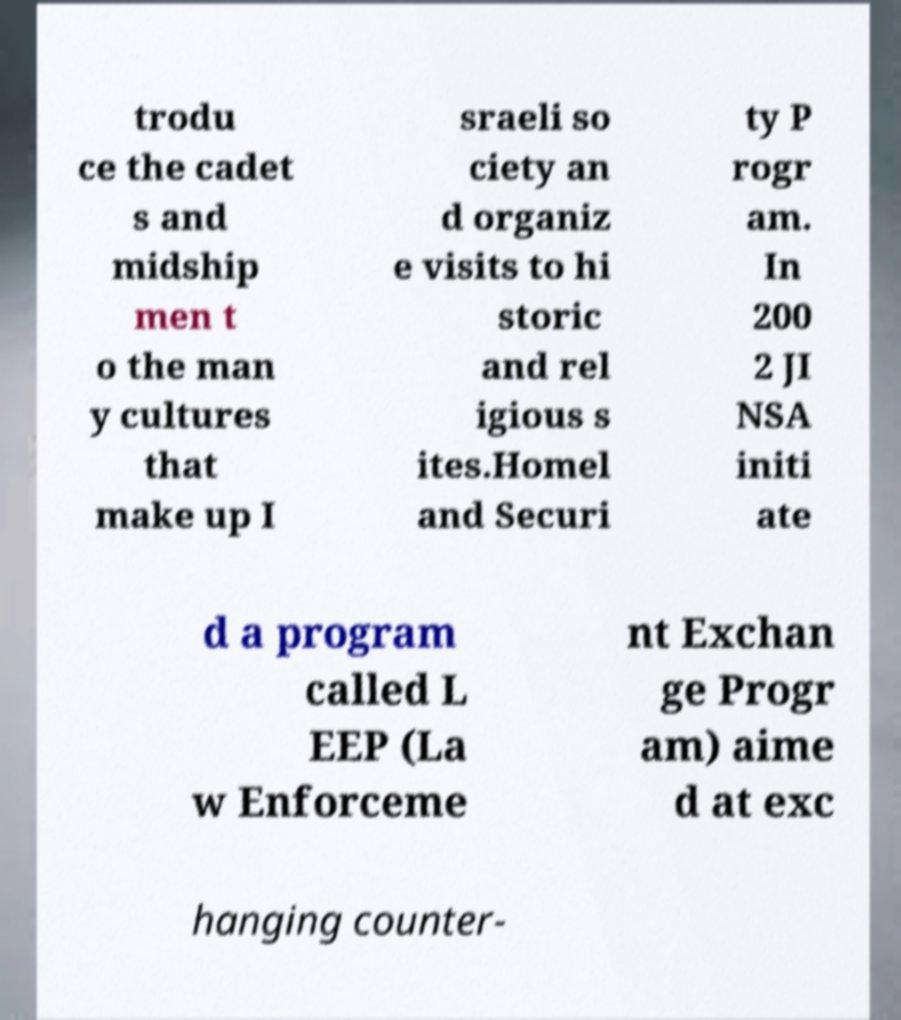Could you extract and type out the text from this image? trodu ce the cadet s and midship men t o the man y cultures that make up I sraeli so ciety an d organiz e visits to hi storic and rel igious s ites.Homel and Securi ty P rogr am. In 200 2 JI NSA initi ate d a program called L EEP (La w Enforceme nt Exchan ge Progr am) aime d at exc hanging counter- 